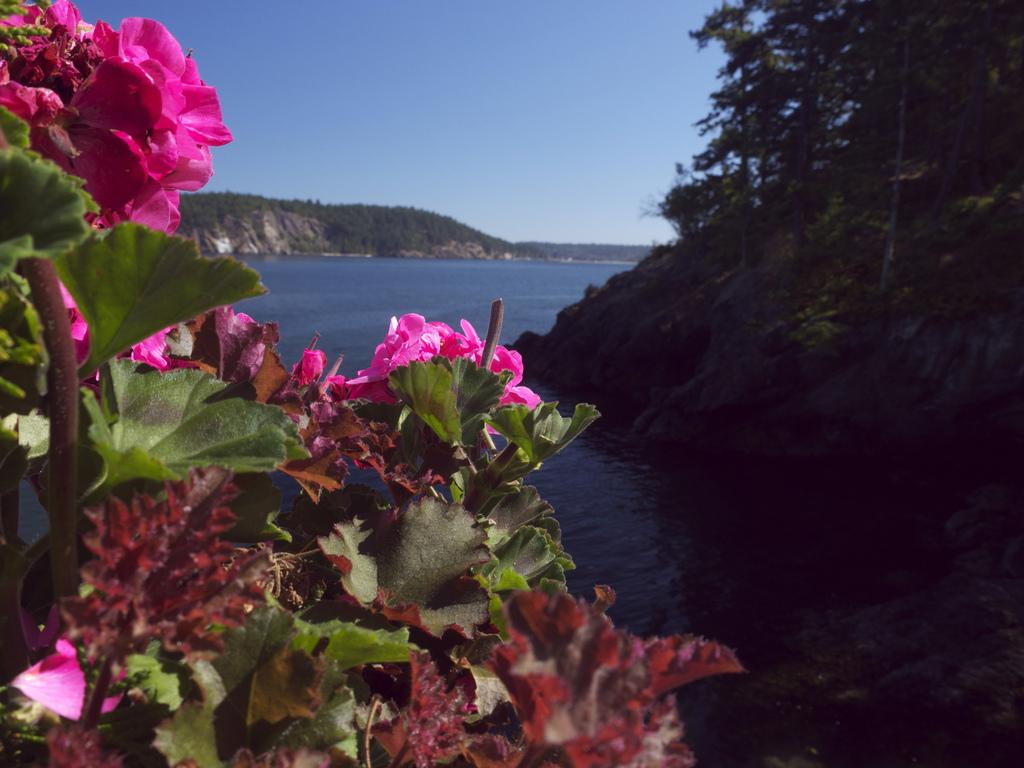What type of vegetation is in the front of the image? There are flowers in the front of the image. Where is the tree located in the image? The tree is on the right side of the image. What can be seen at the bottom of the image? There is water visible at the bottom of the image. What is visible at the top of the image? The sky is visible at the top of the image. Where is the shelf located in the image? There is no shelf present in the image. What type of connection can be seen between the flowers and the tree in the image? There is no connection between the flowers and the tree in the image; they are separate entities. 